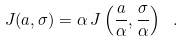Convert formula to latex. <formula><loc_0><loc_0><loc_500><loc_500>J ( a , \sigma ) = \alpha \, J \left ( \frac { a } { \alpha } , \frac { \sigma } { \alpha } \right ) \ .</formula> 